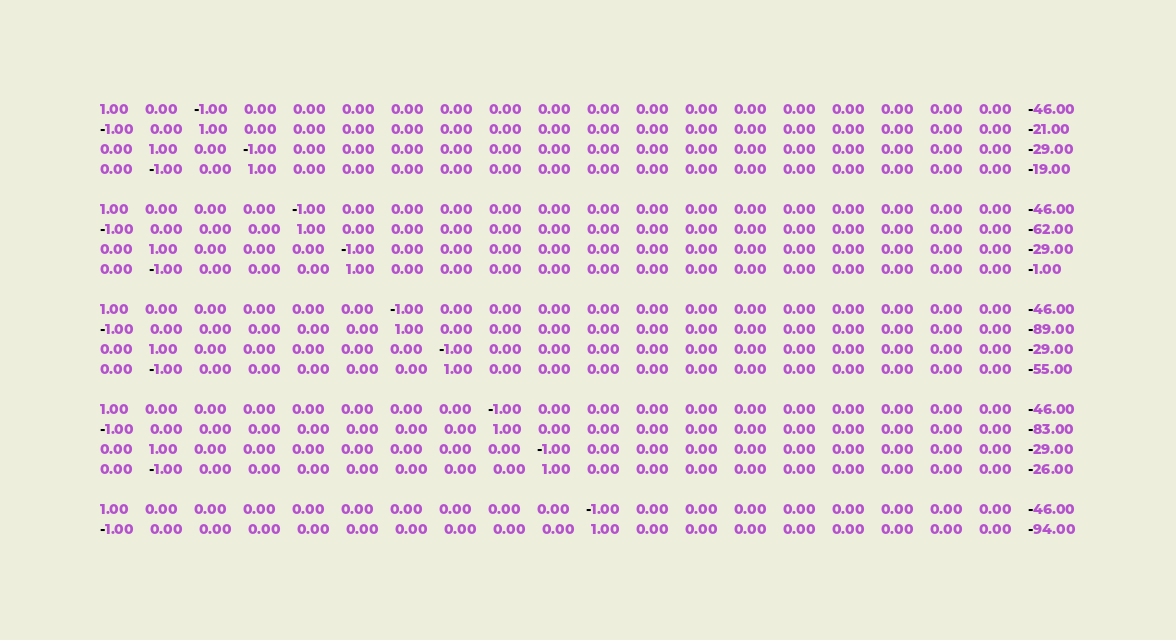<code> <loc_0><loc_0><loc_500><loc_500><_Matlab_>1.00	0.00	-1.00	0.00	0.00	0.00	0.00	0.00	0.00	0.00	0.00	0.00	0.00	0.00	0.00	0.00	0.00	0.00	0.00	-46.00
-1.00	0.00	1.00	0.00	0.00	0.00	0.00	0.00	0.00	0.00	0.00	0.00	0.00	0.00	0.00	0.00	0.00	0.00	0.00	-21.00
0.00	1.00	0.00	-1.00	0.00	0.00	0.00	0.00	0.00	0.00	0.00	0.00	0.00	0.00	0.00	0.00	0.00	0.00	0.00	-29.00
0.00	-1.00	0.00	1.00	0.00	0.00	0.00	0.00	0.00	0.00	0.00	0.00	0.00	0.00	0.00	0.00	0.00	0.00	0.00	-19.00

1.00	0.00	0.00	0.00	-1.00	0.00	0.00	0.00	0.00	0.00	0.00	0.00	0.00	0.00	0.00	0.00	0.00	0.00	0.00	-46.00
-1.00	0.00	0.00	0.00	1.00	0.00	0.00	0.00	0.00	0.00	0.00	0.00	0.00	0.00	0.00	0.00	0.00	0.00	0.00	-62.00
0.00	1.00	0.00	0.00	0.00	-1.00	0.00	0.00	0.00	0.00	0.00	0.00	0.00	0.00	0.00	0.00	0.00	0.00	0.00	-29.00
0.00	-1.00	0.00	0.00	0.00	1.00	0.00	0.00	0.00	0.00	0.00	0.00	0.00	0.00	0.00	0.00	0.00	0.00	0.00	-1.00

1.00	0.00	0.00	0.00	0.00	0.00	-1.00	0.00	0.00	0.00	0.00	0.00	0.00	0.00	0.00	0.00	0.00	0.00	0.00	-46.00
-1.00	0.00	0.00	0.00	0.00	0.00	1.00	0.00	0.00	0.00	0.00	0.00	0.00	0.00	0.00	0.00	0.00	0.00	0.00	-89.00
0.00	1.00	0.00	0.00	0.00	0.00	0.00	-1.00	0.00	0.00	0.00	0.00	0.00	0.00	0.00	0.00	0.00	0.00	0.00	-29.00
0.00	-1.00	0.00	0.00	0.00	0.00	0.00	1.00	0.00	0.00	0.00	0.00	0.00	0.00	0.00	0.00	0.00	0.00	0.00	-55.00

1.00	0.00	0.00	0.00	0.00	0.00	0.00	0.00	-1.00	0.00	0.00	0.00	0.00	0.00	0.00	0.00	0.00	0.00	0.00	-46.00
-1.00	0.00	0.00	0.00	0.00	0.00	0.00	0.00	1.00	0.00	0.00	0.00	0.00	0.00	0.00	0.00	0.00	0.00	0.00	-83.00
0.00	1.00	0.00	0.00	0.00	0.00	0.00	0.00	0.00	-1.00	0.00	0.00	0.00	0.00	0.00	0.00	0.00	0.00	0.00	-29.00
0.00	-1.00	0.00	0.00	0.00	0.00	0.00	0.00	0.00	1.00	0.00	0.00	0.00	0.00	0.00	0.00	0.00	0.00	0.00	-26.00

1.00	0.00	0.00	0.00	0.00	0.00	0.00	0.00	0.00	0.00	-1.00	0.00	0.00	0.00	0.00	0.00	0.00	0.00	0.00	-46.00
-1.00	0.00	0.00	0.00	0.00	0.00	0.00	0.00	0.00	0.00	1.00	0.00	0.00	0.00	0.00	0.00	0.00	0.00	0.00	-94.00</code> 